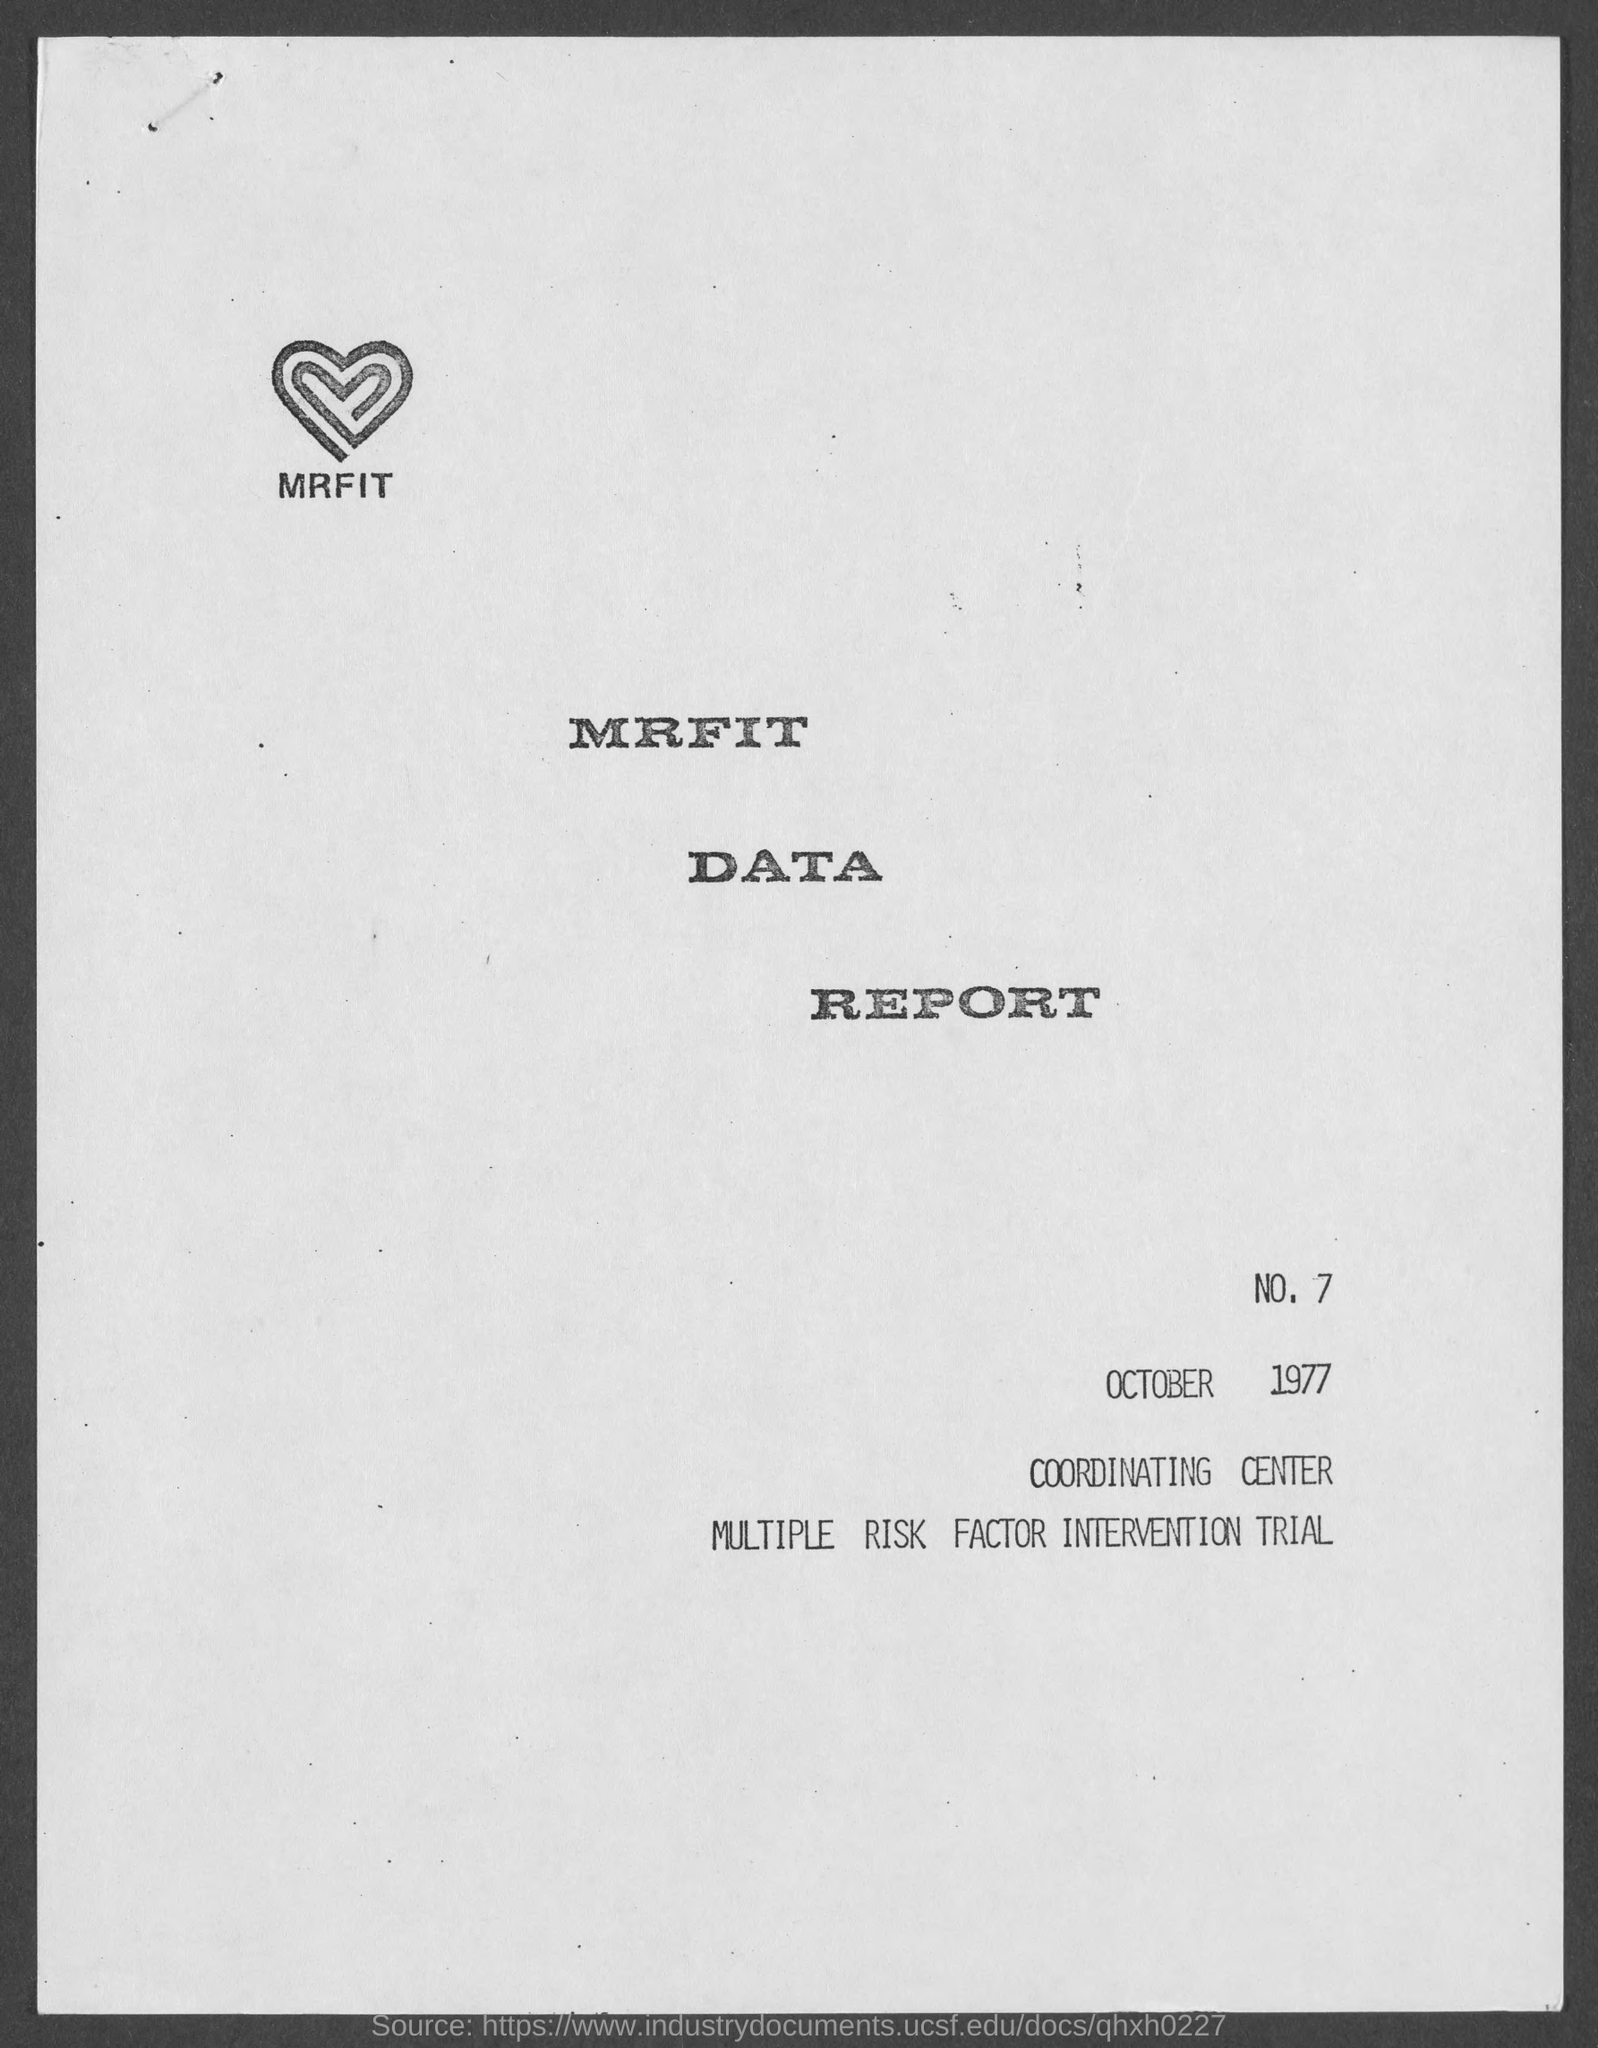Highlight a few significant elements in this photo. The document contains a reference to a date of October 1977. 